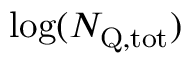Convert formula to latex. <formula><loc_0><loc_0><loc_500><loc_500>\log ( { N _ { Q , t o t } } )</formula> 